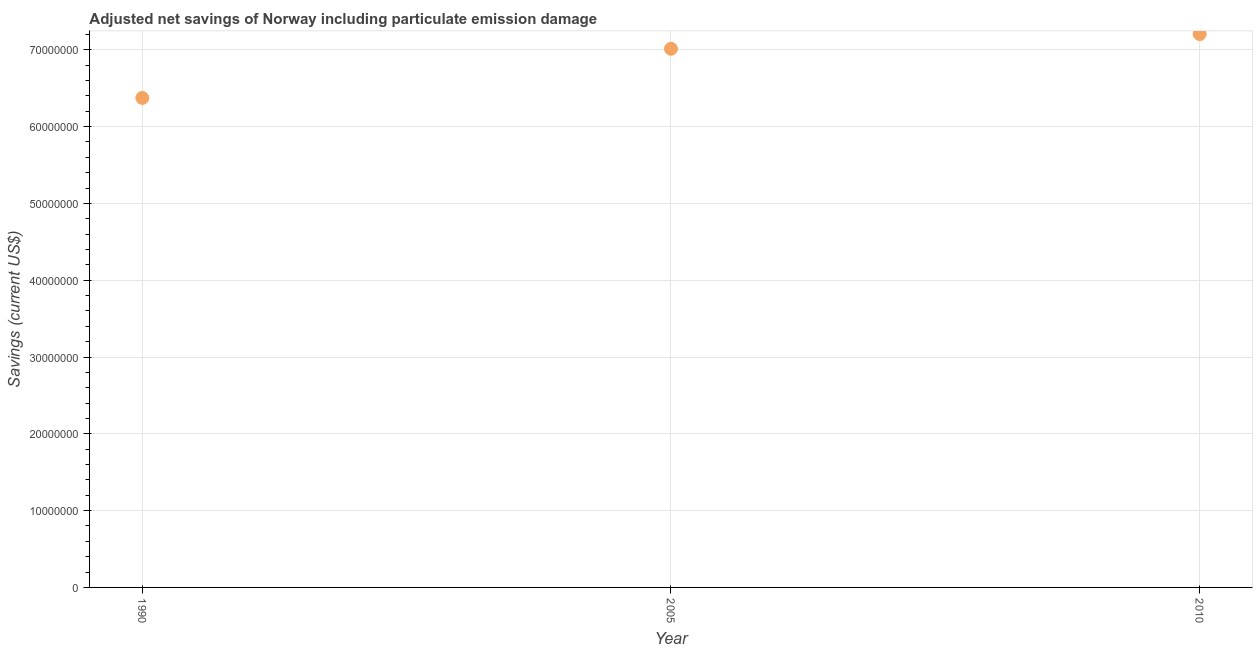What is the adjusted net savings in 2005?
Your answer should be compact. 7.01e+07. Across all years, what is the maximum adjusted net savings?
Offer a very short reply. 7.21e+07. Across all years, what is the minimum adjusted net savings?
Ensure brevity in your answer.  6.37e+07. In which year was the adjusted net savings minimum?
Your response must be concise. 1990. What is the sum of the adjusted net savings?
Provide a succinct answer. 2.06e+08. What is the difference between the adjusted net savings in 1990 and 2005?
Offer a very short reply. -6.40e+06. What is the average adjusted net savings per year?
Keep it short and to the point. 6.86e+07. What is the median adjusted net savings?
Give a very brief answer. 7.01e+07. Do a majority of the years between 2005 and 2010 (inclusive) have adjusted net savings greater than 28000000 US$?
Provide a short and direct response. Yes. What is the ratio of the adjusted net savings in 2005 to that in 2010?
Offer a terse response. 0.97. Is the adjusted net savings in 1990 less than that in 2010?
Provide a short and direct response. Yes. Is the difference between the adjusted net savings in 1990 and 2010 greater than the difference between any two years?
Your answer should be very brief. Yes. What is the difference between the highest and the second highest adjusted net savings?
Your answer should be compact. 1.92e+06. What is the difference between the highest and the lowest adjusted net savings?
Your answer should be compact. 8.32e+06. How many years are there in the graph?
Offer a very short reply. 3. What is the difference between two consecutive major ticks on the Y-axis?
Keep it short and to the point. 1.00e+07. Are the values on the major ticks of Y-axis written in scientific E-notation?
Offer a terse response. No. Does the graph contain grids?
Your answer should be very brief. Yes. What is the title of the graph?
Keep it short and to the point. Adjusted net savings of Norway including particulate emission damage. What is the label or title of the X-axis?
Make the answer very short. Year. What is the label or title of the Y-axis?
Offer a terse response. Savings (current US$). What is the Savings (current US$) in 1990?
Your answer should be very brief. 6.37e+07. What is the Savings (current US$) in 2005?
Your response must be concise. 7.01e+07. What is the Savings (current US$) in 2010?
Give a very brief answer. 7.21e+07. What is the difference between the Savings (current US$) in 1990 and 2005?
Give a very brief answer. -6.40e+06. What is the difference between the Savings (current US$) in 1990 and 2010?
Your response must be concise. -8.32e+06. What is the difference between the Savings (current US$) in 2005 and 2010?
Keep it short and to the point. -1.92e+06. What is the ratio of the Savings (current US$) in 1990 to that in 2005?
Provide a succinct answer. 0.91. What is the ratio of the Savings (current US$) in 1990 to that in 2010?
Provide a succinct answer. 0.89. 